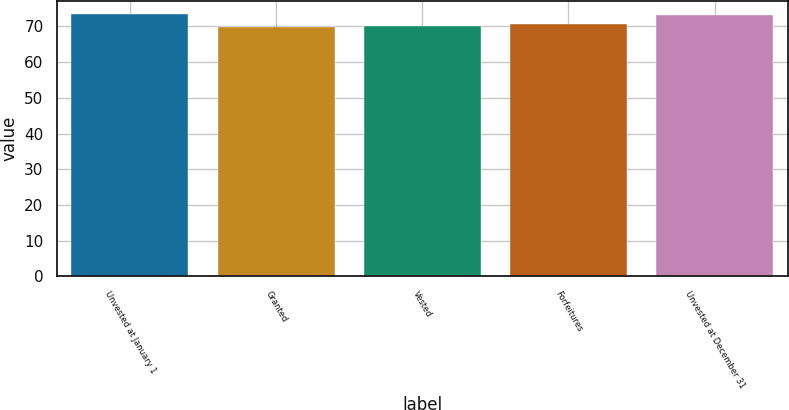<chart> <loc_0><loc_0><loc_500><loc_500><bar_chart><fcel>Unvested at January 1<fcel>Granted<fcel>Vested<fcel>Forfeitures<fcel>Unvested at December 31<nl><fcel>73.53<fcel>69.87<fcel>70.21<fcel>70.55<fcel>73.19<nl></chart> 